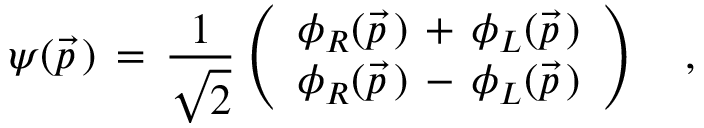<formula> <loc_0><loc_0><loc_500><loc_500>\psi ( \vec { p } \, ) \, = \, { \frac { 1 } { \sqrt { 2 } } } \left ( \begin{array} { c c } { { \phi _ { R } ( \vec { p } \, ) \, + \, \phi _ { L } ( \vec { p } \, ) } } \\ { { \phi _ { R } ( \vec { p } \, ) \, - \, \phi _ { L } ( \vec { p } \, ) } } \end{array} \right ) \quad ,</formula> 